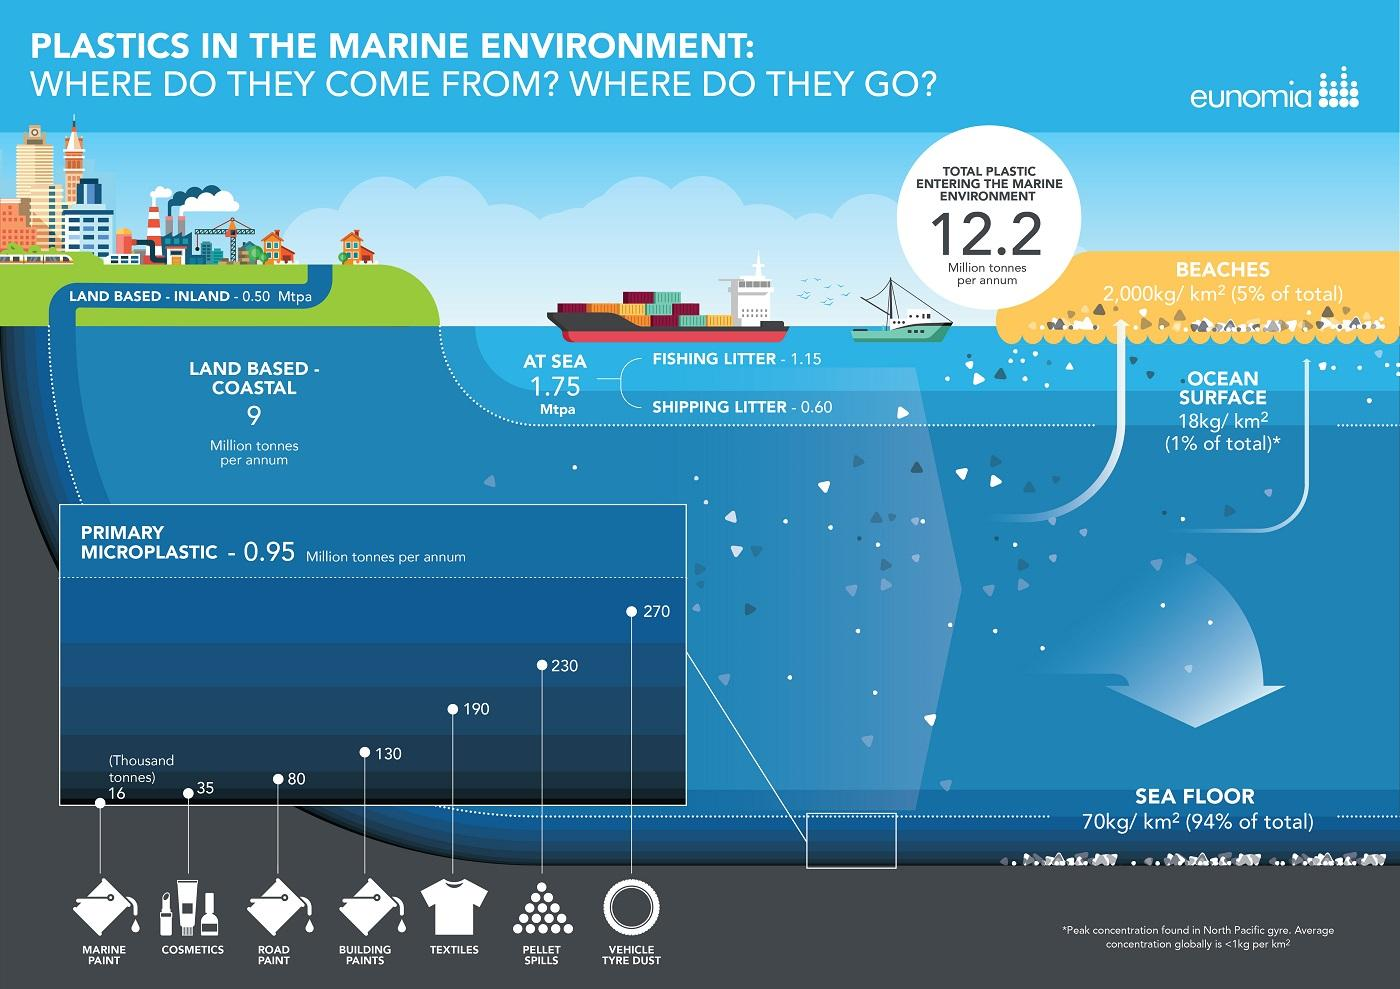Highlight a few significant elements in this photo. Microplastics are small plastic particles that are commonly found in the ocean. Vehicle tyre dust is the primary microplastic that is found in the largest amount in oceans. Microplastic particles, which are small pieces of plastic less than 5 millimeters in size, are prevalent in the oceans and have been found to be present in significant quantities in building paints. According to recent research, approximately 130 thousand tonnes of microplastic are found in the oceans, with a significant portion of this originating from the use of building paints. A recent study has found that 190,000 metric tons of textile microplastic are present in the sea. 